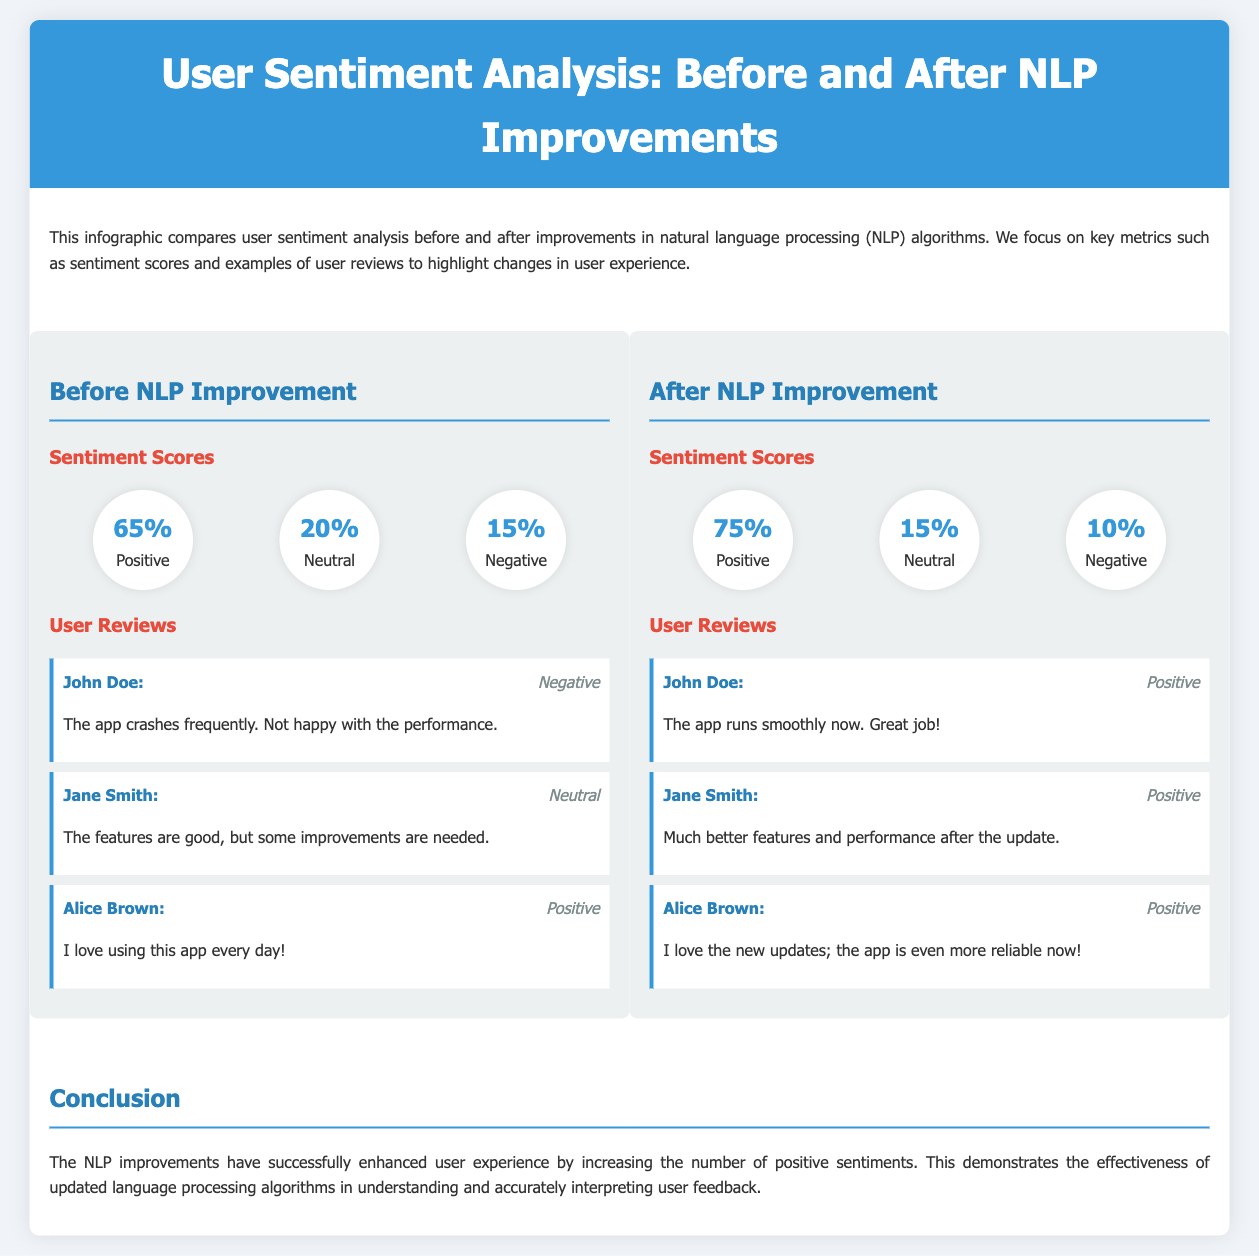What is the positive sentiment score before NLP improvement? The positive sentiment score before NLP improvement is found in the section titled "Sentiment Scores" under "Before NLP Improvement," which shows 65%.
Answer: 65% What is the percentage of negative sentiment after NLP improvements? The percentage of negative sentiment after NLP improvements is listed in the "Sentiment Scores" section under "After NLP Improvement," which indicates 10%.
Answer: 10% How many user reviews are presented for the "Before NLP Improvement"? The "User Reviews" section under "Before NLP Improvement" includes three user reviews as indicated in the document.
Answer: three Which user expressed a negative sentiment before the NLP improvements? John Doe's review under "User Reviews" indicates a negative sentiment, stating the app crashes frequently.
Answer: John Doe What is the main conclusion drawn from the infographic? The conclusion states that the NLP improvements have enhanced user experience by increasing positive sentiments, reflecting the document's overall findings.
Answer: Increased positive sentiments Which user provided a positive review about the app performance after NLP improvements? The user reviews section after the NLP improvement highlights John Doe as providing a positive review about the app running smoothly now.
Answer: John Doe What is the total number of different sentiment categories displayed in the scores? The sentiment scores are divided into three different categories: Positive, Neutral, and Negative, as seen in both sections.
Answer: three What color is used for the header background in the document? The header background is described in the styling section of the document as having a color of #3498db.
Answer: #3498db 